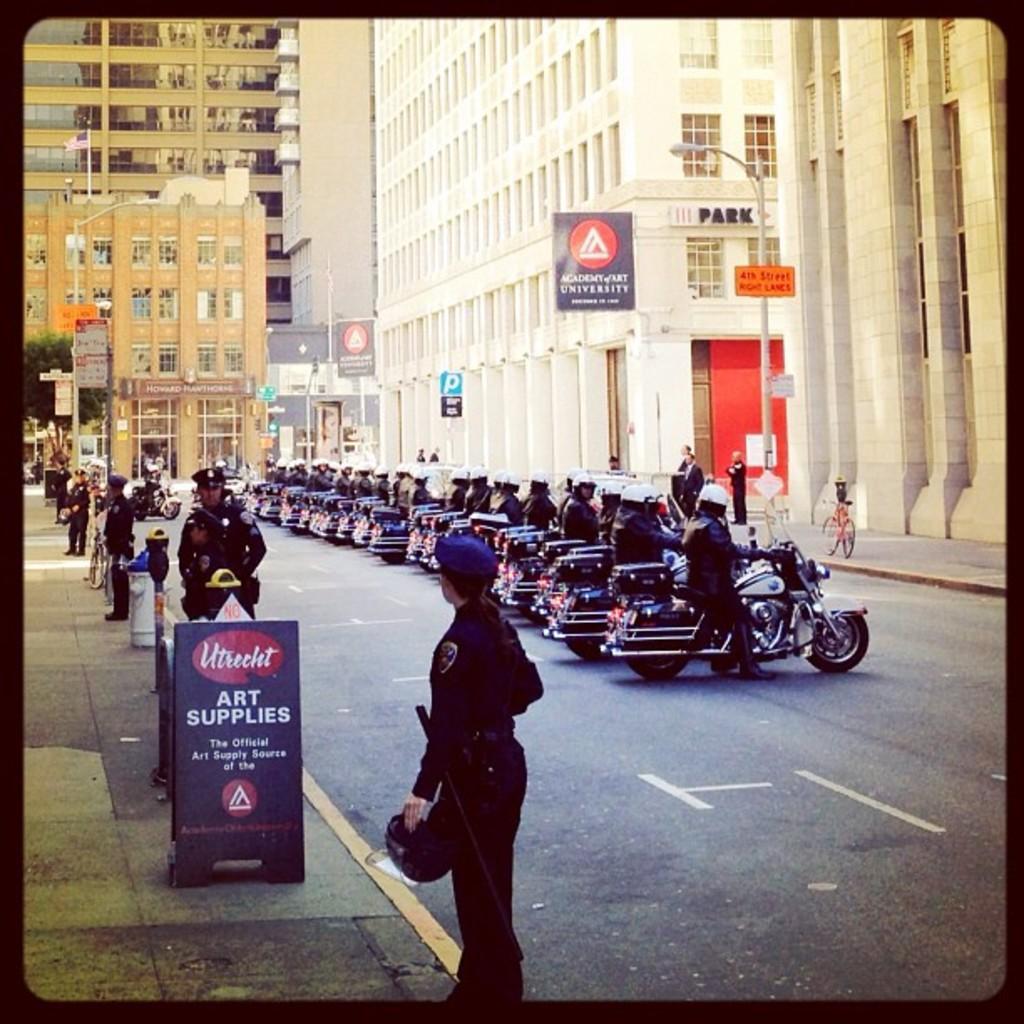Can you describe this image briefly? In this image we can see many buildings. There are many people in the image. There are many vehicles in the image. There are many advertising boards in the image. There are few people standing. 